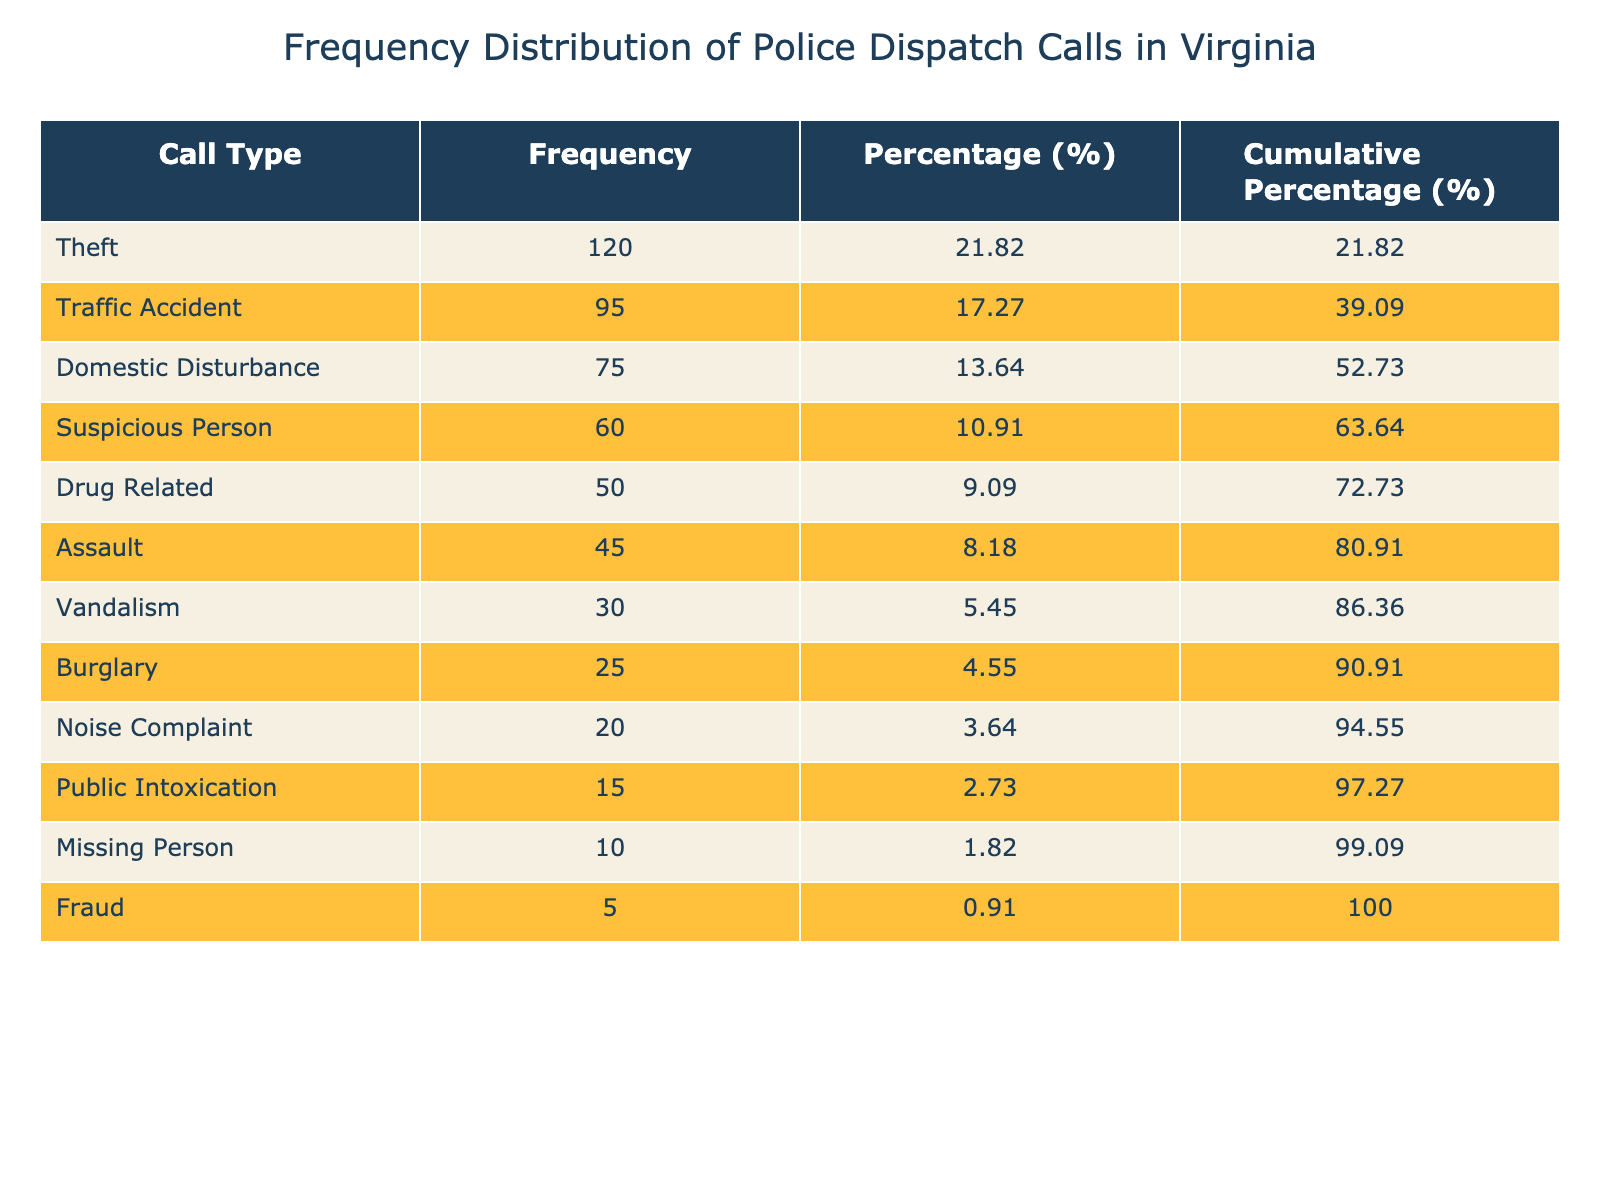What is the total frequency of all calls received? To find the total frequency, we need to sum the frequency values of all call types: 120 + 95 + 75 + 60 + 50 + 45 + 30 + 25 + 20 + 15 + 10 + 5 =  525.
Answer: 525 Which call type has the highest frequency? The call type with the highest frequency is Theft, which has a frequency of 120.
Answer: Theft What percentage of calls are related to Domestic Disturbance? To find the percentage for Domestic Disturbance, we take its frequency (75) and divide by the total frequency (525) and then multiply by 100: (75 / 525) * 100 ≈ 14.29%.
Answer: 14.29% How many more calls were reported for Theft than for Assault? To find out how many more calls were reported for Theft than for Assault, we subtract the frequency of Assault (45) from Theft (120): 120 - 45 = 75.
Answer: 75 Is the frequency of Fraud calls greater than the frequency of Burglary calls? The frequency of Fraud calls is 5, while the frequency of Burglary calls is 25. Since 5 is less than 25, the answer is no.
Answer: No What is the cumulative percentage of calls for the top three call types? For the top three call types (Theft, Traffic Accident, and Domestic Disturbance), their frequencies are 120, 95, and 75. First, we find their total frequency: 120 + 95 + 75 = 290. Then, to get the cumulative percentage: (290 / 525) * 100 ≈ 55.24%.
Answer: 55.24% How many call types have a frequency of less than 50? Reviewing the table, the call types with a frequency of less than 50 are Drug Related (50), Assault (45), Vandalism (30), Burglary (25), Noise Complaint (20), Public Intoxication (15), Missing Person (10), and Fraud (5), which totals 8 call types.
Answer: 8 What is the difference between the frequency of Noise Complaints and Public Intoxication? To find the difference, subtract the frequency of Public Intoxication (15) from the frequency of Noise Complaint (20): 20 - 15 = 5.
Answer: 5 Which call type has a frequency closest to the average frequency of all calls? First, we need to calculate the average frequency of all calls: 525 (total frequency) divided by 12 (call types) equals 43.75. The frequencies closest to this average are Assault (45) and Vandalism (30). The absolute difference for Assault is 1.25 (45-43.75) and for Vandalism is 13.75 (30-43.75), thus Assault is the closest.
Answer: Assault 